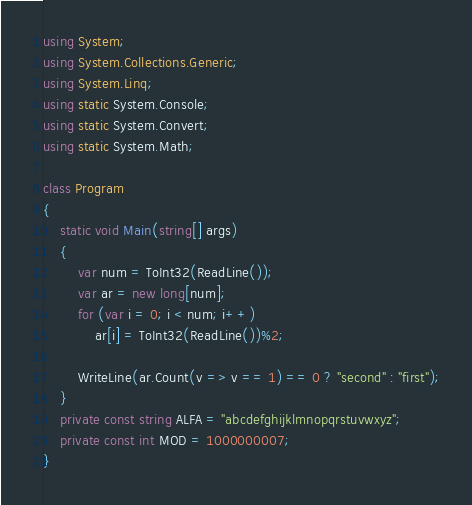<code> <loc_0><loc_0><loc_500><loc_500><_C#_>using System;
using System.Collections.Generic;
using System.Linq;
using static System.Console;
using static System.Convert;
using static System.Math;

class Program
{
    static void Main(string[] args)
    {
        var num = ToInt32(ReadLine());
        var ar = new long[num];
        for (var i = 0; i < num; i++)
            ar[i] = ToInt32(ReadLine())%2;

        WriteLine(ar.Count(v => v == 1) == 0 ? "second" : "first");
    }
    private const string ALFA = "abcdefghijklmnopqrstuvwxyz";
    private const int MOD = 1000000007;
}
</code> 